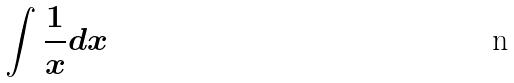<formula> <loc_0><loc_0><loc_500><loc_500>\int \frac { 1 } { x } d x</formula> 